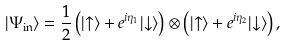Convert formula to latex. <formula><loc_0><loc_0><loc_500><loc_500>| \Psi _ { \text {in} } \rangle = \frac { 1 } { 2 } \left ( | { \uparrow } \rangle + e ^ { i \eta _ { 1 } } | { \downarrow } \rangle \right ) \otimes \left ( | { \uparrow } \rangle + e ^ { i \eta _ { 2 } } | { \downarrow } \rangle \right ) ,</formula> 